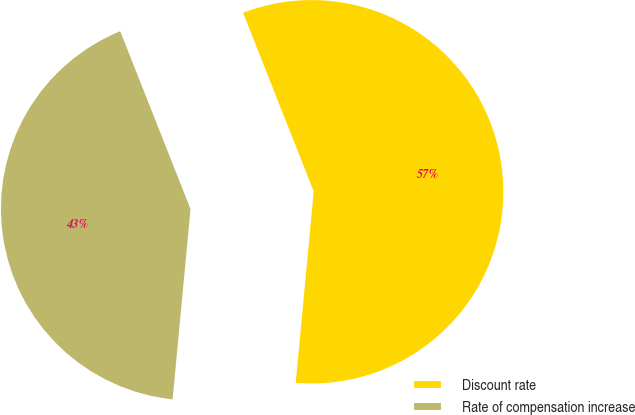Convert chart to OTSL. <chart><loc_0><loc_0><loc_500><loc_500><pie_chart><fcel>Discount rate<fcel>Rate of compensation increase<nl><fcel>57.49%<fcel>42.51%<nl></chart> 